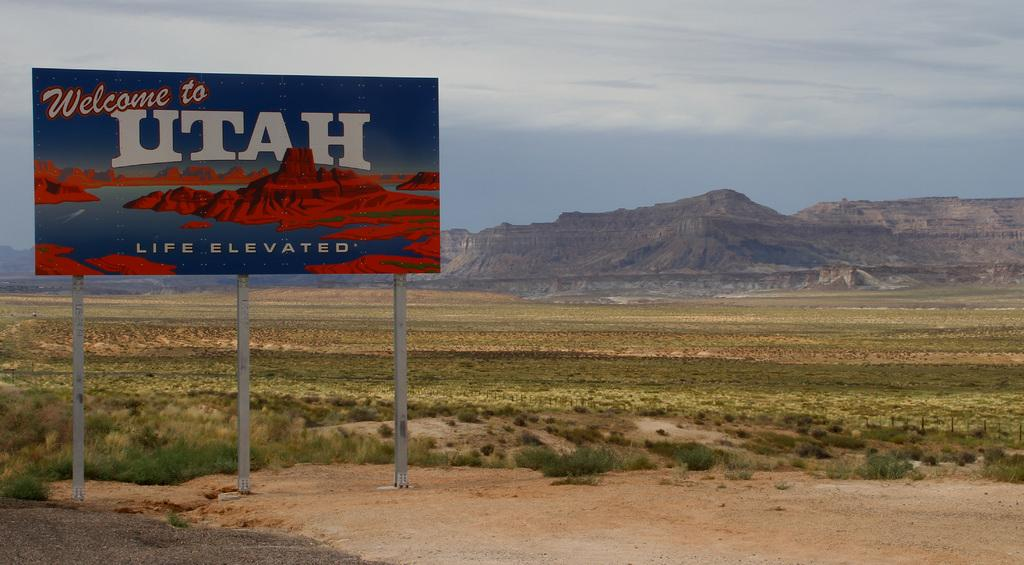Provide a one-sentence caption for the provided image. A welcome to Utah sign sits in front of a beautiful mountain side. 